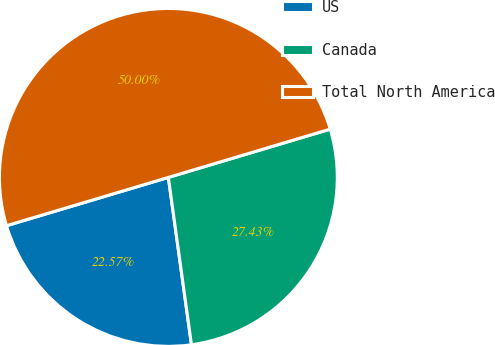Convert chart to OTSL. <chart><loc_0><loc_0><loc_500><loc_500><pie_chart><fcel>US<fcel>Canada<fcel>Total North America<nl><fcel>22.57%<fcel>27.43%<fcel>50.0%<nl></chart> 